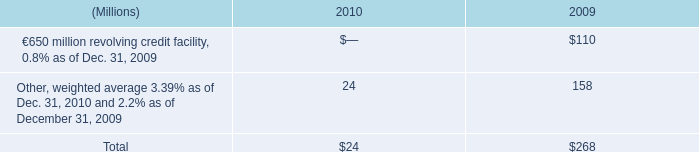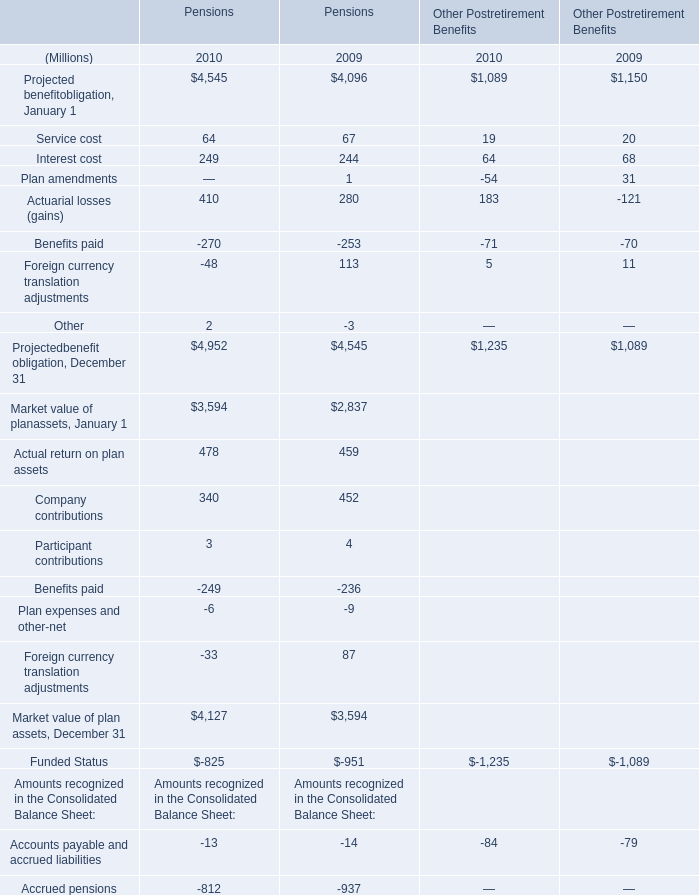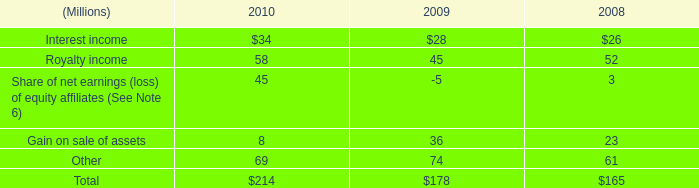What is the percentage of Actuarial losses (gains) for Pensions in relation to the total Projectedbenefit obligation, December 31 in 2010? 
Computations: (410 / 4952)
Answer: 0.08279. 